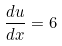<formula> <loc_0><loc_0><loc_500><loc_500>\frac { d u } { d x } = 6</formula> 